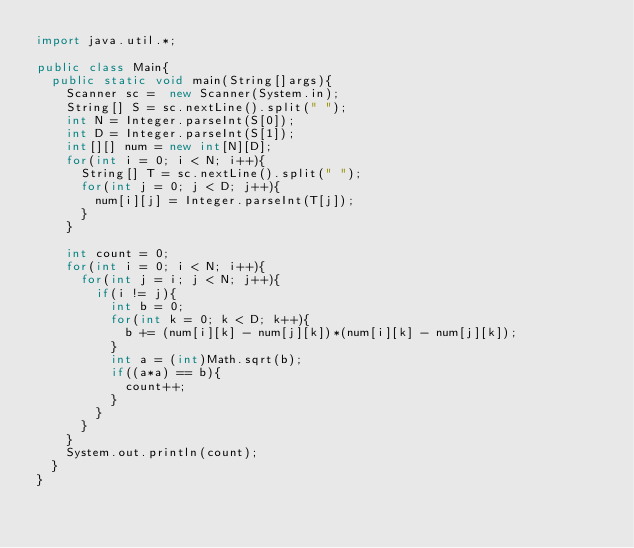<code> <loc_0><loc_0><loc_500><loc_500><_Java_>import java.util.*;
 
public class Main{
  public static void main(String[]args){
    Scanner sc =  new Scanner(System.in);
    String[] S = sc.nextLine().split(" ");
    int N = Integer.parseInt(S[0]);
    int D = Integer.parseInt(S[1]);
    int[][] num = new int[N][D];
    for(int i = 0; i < N; i++){
      String[] T = sc.nextLine().split(" ");
      for(int j = 0; j < D; j++){
        num[i][j] = Integer.parseInt(T[j]);
      }
    }
    
    int count = 0;
    for(int i = 0; i < N; i++){
      for(int j = i; j < N; j++){
        if(i != j){
          int b = 0;
          for(int k = 0; k < D; k++){
            b += (num[i][k] - num[j][k])*(num[i][k] - num[j][k]);
          }
          int a = (int)Math.sqrt(b);
          if((a*a) == b){
            count++;
          }
        }
      }
    }
    System.out.println(count);
  }
}</code> 